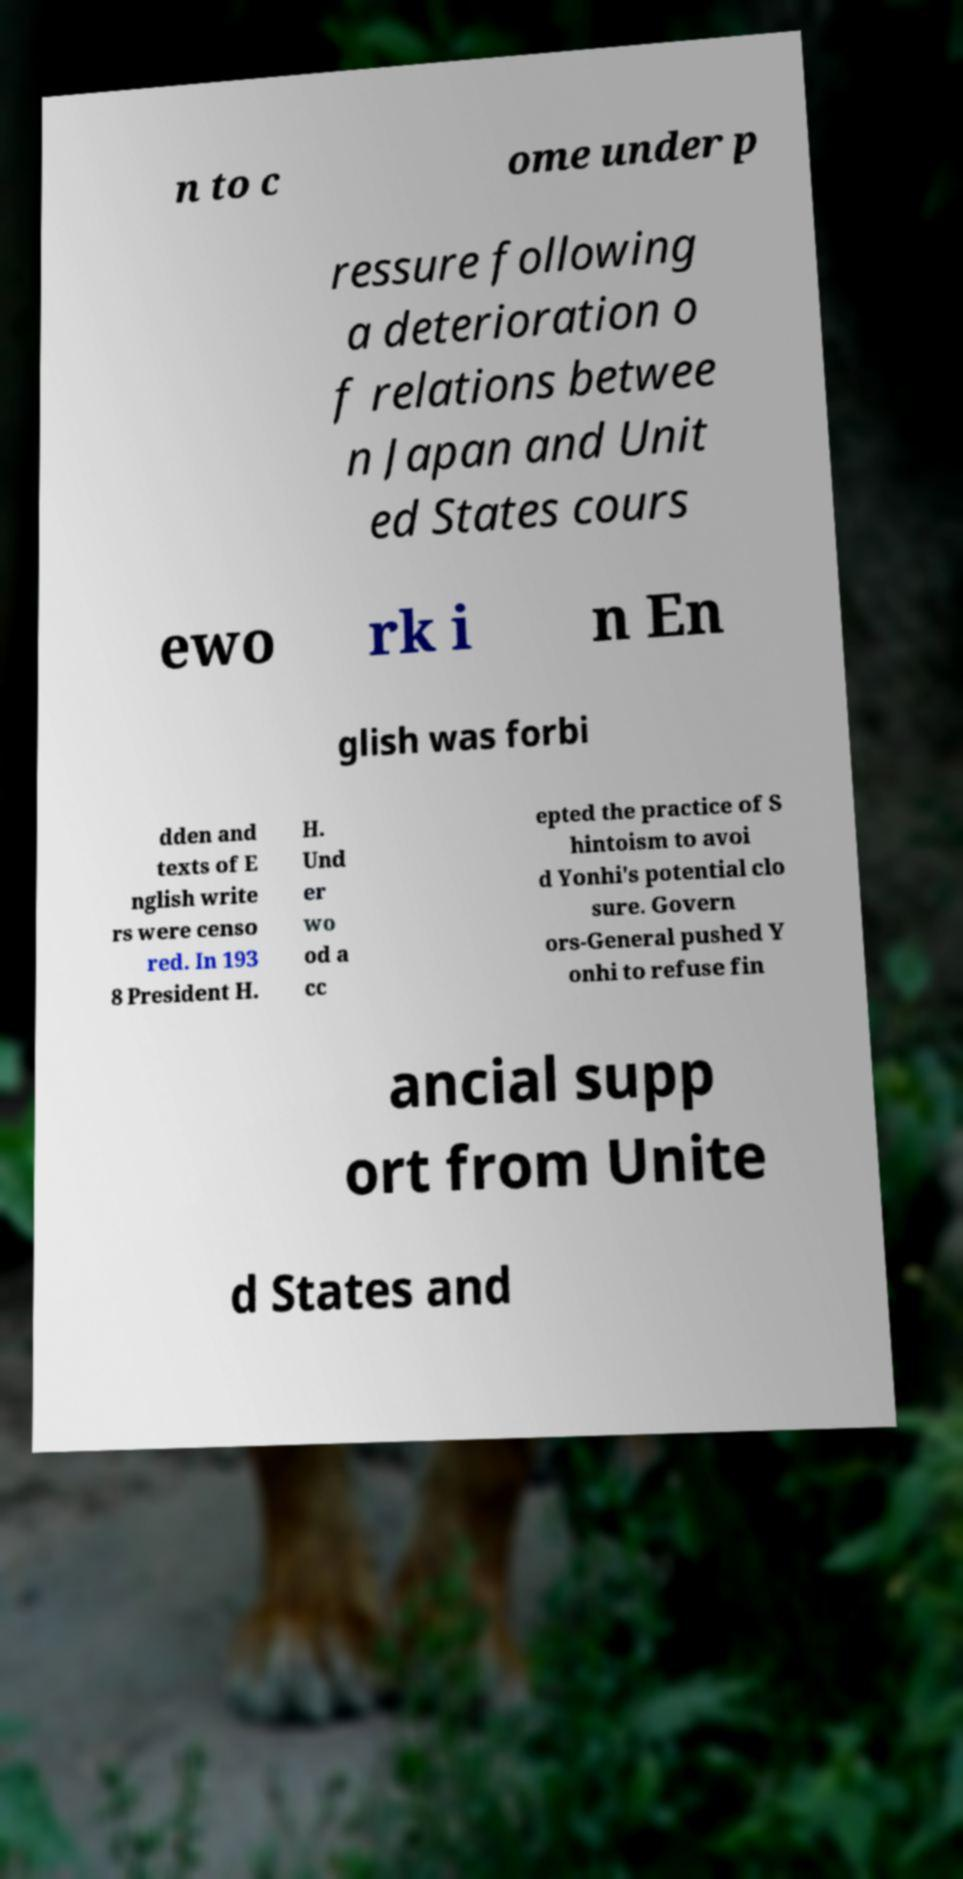What messages or text are displayed in this image? I need them in a readable, typed format. n to c ome under p ressure following a deterioration o f relations betwee n Japan and Unit ed States cours ewo rk i n En glish was forbi dden and texts of E nglish write rs were censo red. In 193 8 President H. H. Und er wo od a cc epted the practice of S hintoism to avoi d Yonhi's potential clo sure. Govern ors-General pushed Y onhi to refuse fin ancial supp ort from Unite d States and 